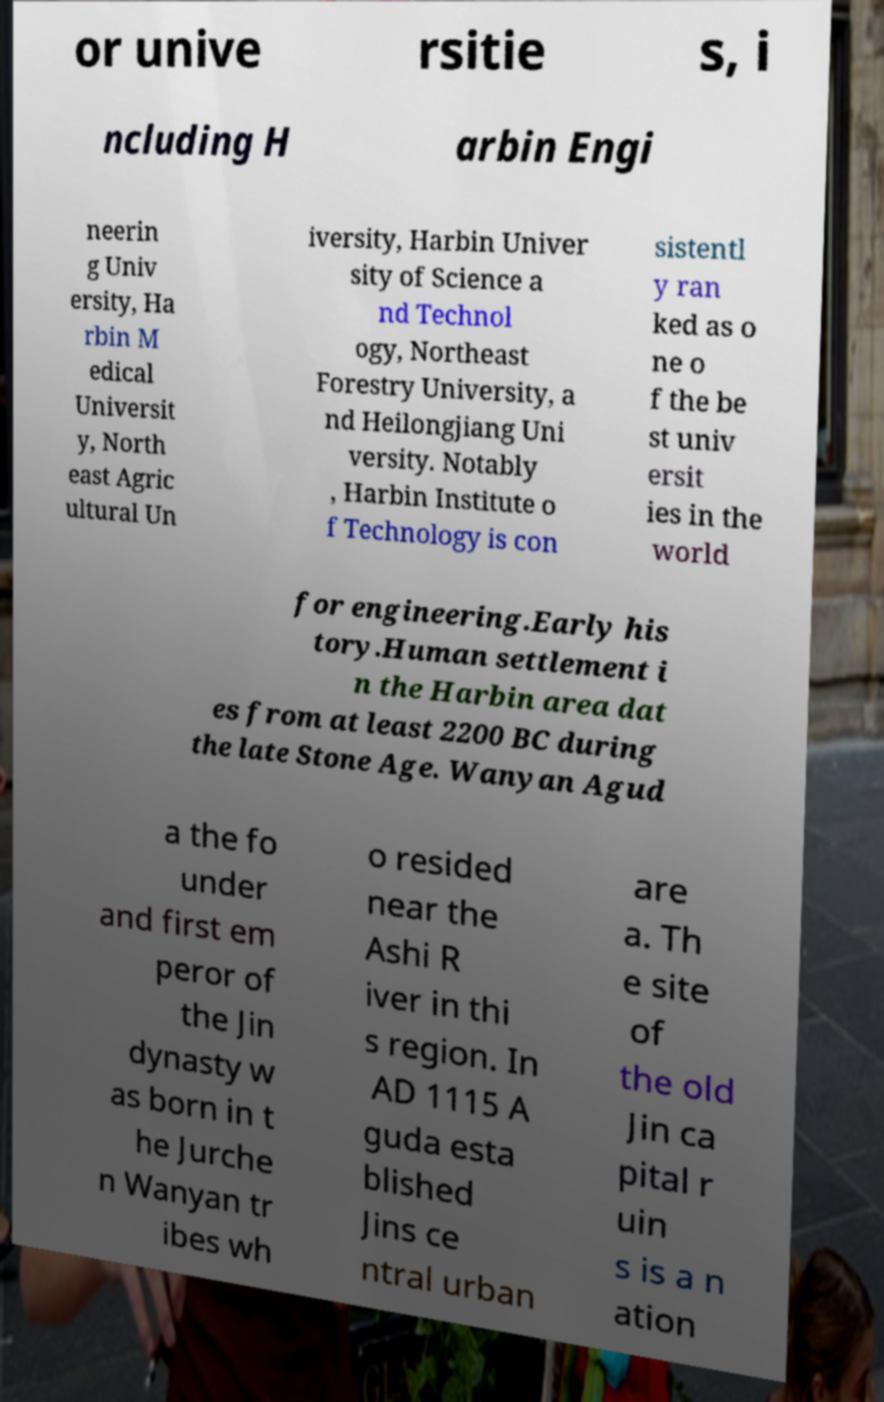There's text embedded in this image that I need extracted. Can you transcribe it verbatim? or unive rsitie s, i ncluding H arbin Engi neerin g Univ ersity, Ha rbin M edical Universit y, North east Agric ultural Un iversity, Harbin Univer sity of Science a nd Technol ogy, Northeast Forestry University, a nd Heilongjiang Uni versity. Notably , Harbin Institute o f Technology is con sistentl y ran ked as o ne o f the be st univ ersit ies in the world for engineering.Early his tory.Human settlement i n the Harbin area dat es from at least 2200 BC during the late Stone Age. Wanyan Agud a the fo under and first em peror of the Jin dynasty w as born in t he Jurche n Wanyan tr ibes wh o resided near the Ashi R iver in thi s region. In AD 1115 A guda esta blished Jins ce ntral urban are a. Th e site of the old Jin ca pital r uin s is a n ation 